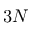Convert formula to latex. <formula><loc_0><loc_0><loc_500><loc_500>3 N</formula> 